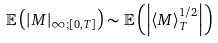<formula> <loc_0><loc_0><loc_500><loc_500>\mathbb { E } \left ( \left | M \right | _ { \infty \text {;} [ 0 , T ] } \right ) \sim \mathbb { E } \left ( \left | \left \langle M \right \rangle _ { T } ^ { 1 / 2 } \right | \right )</formula> 